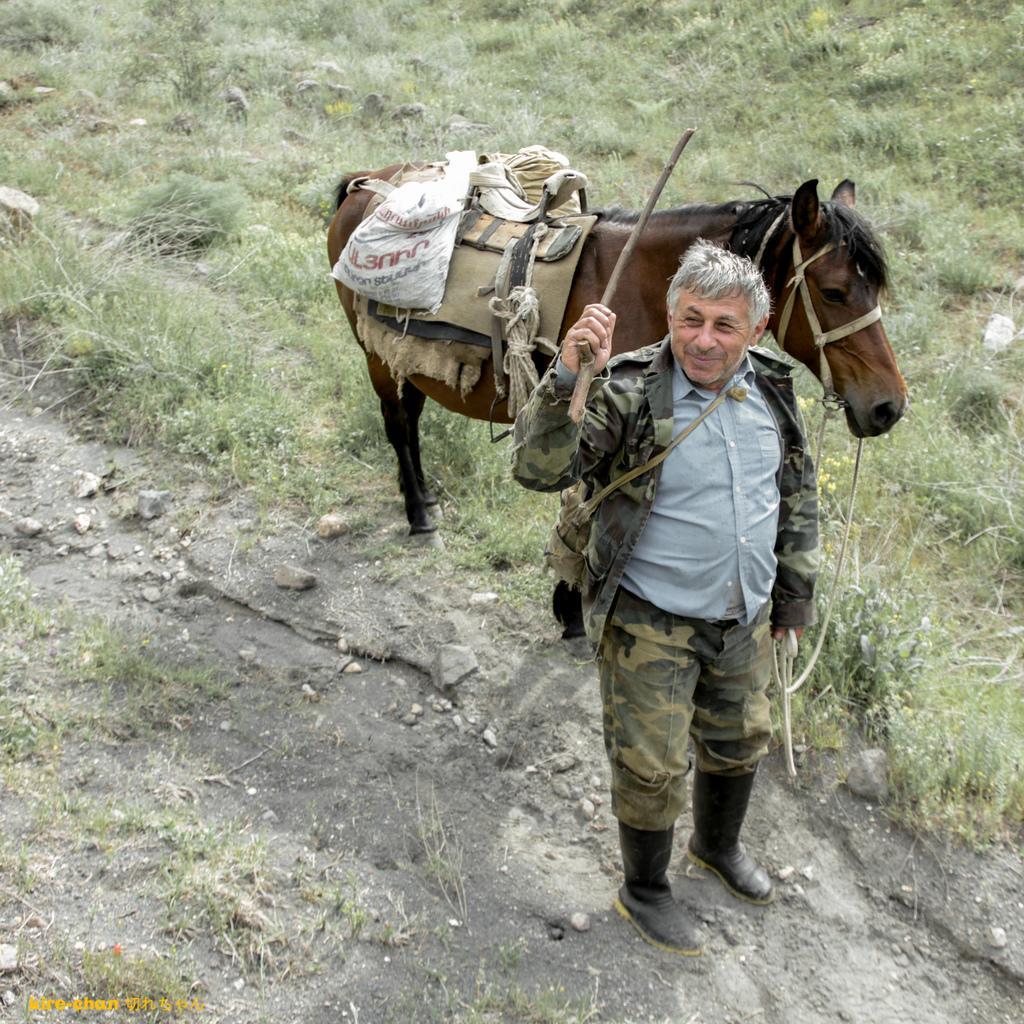How would you summarize this image in a sentence or two? In this image I can see a person wearing military uniform is standing and holding a stick and a rope in his hand. I can see the rope is tied to the horse which is brown and black in color. I can see few clothes and a bag on the horse. I can see the ground and some grass on the ground. 